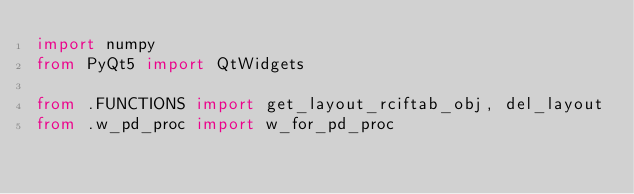<code> <loc_0><loc_0><loc_500><loc_500><_Python_>import numpy
from PyQt5 import QtWidgets

from .FUNCTIONS import get_layout_rciftab_obj, del_layout
from .w_pd_proc import w_for_pd_proc</code> 